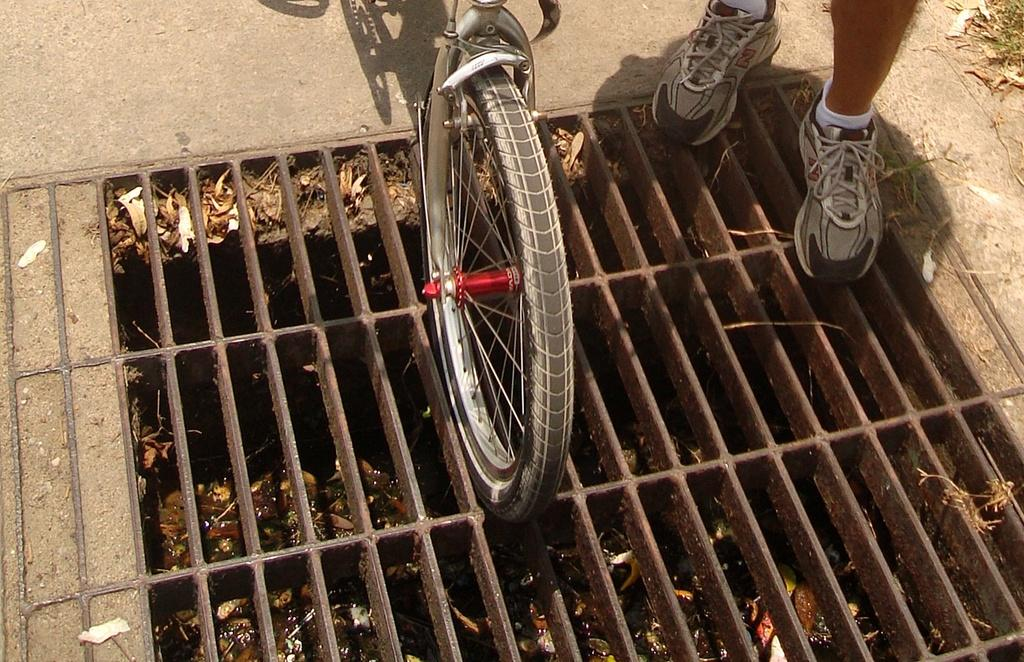What is the main object in the image? There is a cycle in the image. Where is the cycle located? The cycle is on a drainage pit. Are there any people visible in the image? Yes, there is a man in the top right corner of the image. What type of decision can be seen being made by the crowd in the image? There is no crowd present in the image, so it is not possible to determine what decision might be made. 